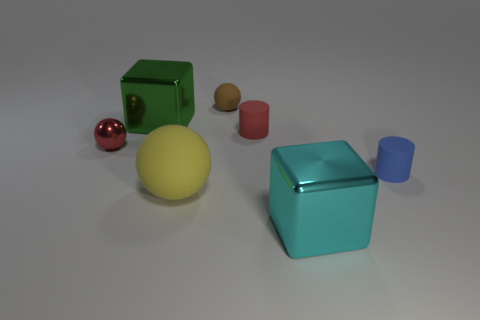What is the size of the other rubber object that is the same shape as the tiny brown thing?
Provide a short and direct response. Large. What number of small cylinders have the same material as the yellow ball?
Make the answer very short. 2. Does the cube that is behind the cyan thing have the same material as the big sphere?
Offer a terse response. No. Are there the same number of tiny red metallic things to the right of the green thing and small purple rubber balls?
Your answer should be very brief. Yes. The red matte thing is what size?
Your response must be concise. Small. What is the material of the object that is the same color as the metal ball?
Offer a very short reply. Rubber. What number of large matte spheres are the same color as the small metallic ball?
Provide a short and direct response. 0. Does the blue rubber object have the same size as the red cylinder?
Provide a succinct answer. Yes. What size is the blue matte thing that is right of the large metallic cube in front of the tiny red cylinder?
Provide a succinct answer. Small. Is the color of the large sphere the same as the cube that is behind the cyan thing?
Offer a very short reply. No. 